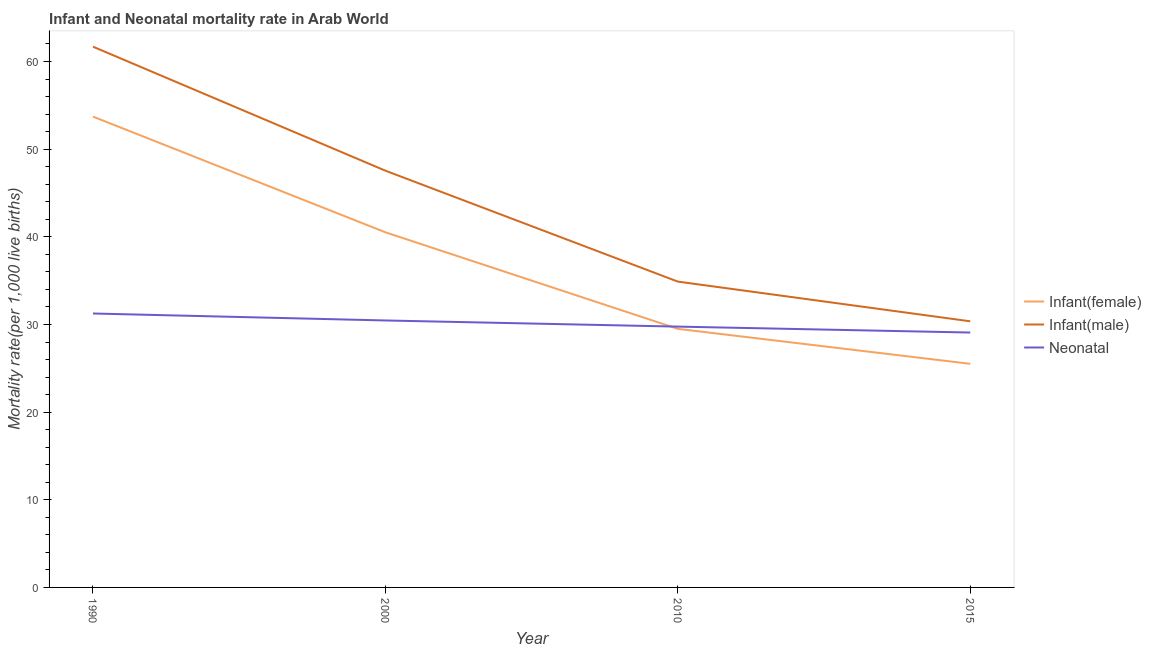How many different coloured lines are there?
Make the answer very short. 3. What is the infant mortality rate(female) in 2015?
Offer a terse response. 25.51. Across all years, what is the maximum neonatal mortality rate?
Provide a short and direct response. 31.25. Across all years, what is the minimum infant mortality rate(male)?
Keep it short and to the point. 30.36. In which year was the infant mortality rate(male) maximum?
Give a very brief answer. 1990. In which year was the infant mortality rate(male) minimum?
Offer a very short reply. 2015. What is the total neonatal mortality rate in the graph?
Your answer should be very brief. 120.54. What is the difference between the neonatal mortality rate in 1990 and that in 2015?
Give a very brief answer. 2.17. What is the difference between the infant mortality rate(female) in 1990 and the infant mortality rate(male) in 2000?
Provide a succinct answer. 6.17. What is the average infant mortality rate(male) per year?
Provide a short and direct response. 43.62. In the year 2015, what is the difference between the infant mortality rate(male) and infant mortality rate(female)?
Your response must be concise. 4.85. In how many years, is the infant mortality rate(male) greater than 44?
Keep it short and to the point. 2. What is the ratio of the infant mortality rate(male) in 1990 to that in 2015?
Provide a short and direct response. 2.03. What is the difference between the highest and the second highest infant mortality rate(male)?
Provide a succinct answer. 14.15. What is the difference between the highest and the lowest neonatal mortality rate?
Make the answer very short. 2.17. Is it the case that in every year, the sum of the infant mortality rate(female) and infant mortality rate(male) is greater than the neonatal mortality rate?
Make the answer very short. Yes. Does the infant mortality rate(female) monotonically increase over the years?
Ensure brevity in your answer.  No. Is the infant mortality rate(female) strictly greater than the infant mortality rate(male) over the years?
Make the answer very short. No. What is the difference between two consecutive major ticks on the Y-axis?
Offer a very short reply. 10. Does the graph contain any zero values?
Give a very brief answer. No. Does the graph contain grids?
Make the answer very short. No. Where does the legend appear in the graph?
Give a very brief answer. Center right. How many legend labels are there?
Give a very brief answer. 3. How are the legend labels stacked?
Give a very brief answer. Vertical. What is the title of the graph?
Your answer should be compact. Infant and Neonatal mortality rate in Arab World. What is the label or title of the X-axis?
Your answer should be compact. Year. What is the label or title of the Y-axis?
Your answer should be compact. Mortality rate(per 1,0 live births). What is the Mortality rate(per 1,000 live births) of Infant(female) in 1990?
Make the answer very short. 53.72. What is the Mortality rate(per 1,000 live births) in Infant(male) in 1990?
Keep it short and to the point. 61.69. What is the Mortality rate(per 1,000 live births) in Neonatal  in 1990?
Provide a succinct answer. 31.25. What is the Mortality rate(per 1,000 live births) in Infant(female) in 2000?
Provide a short and direct response. 40.52. What is the Mortality rate(per 1,000 live births) of Infant(male) in 2000?
Provide a succinct answer. 47.55. What is the Mortality rate(per 1,000 live births) in Neonatal  in 2000?
Your response must be concise. 30.46. What is the Mortality rate(per 1,000 live births) of Infant(female) in 2010?
Provide a short and direct response. 29.5. What is the Mortality rate(per 1,000 live births) in Infant(male) in 2010?
Provide a short and direct response. 34.89. What is the Mortality rate(per 1,000 live births) of Neonatal  in 2010?
Give a very brief answer. 29.76. What is the Mortality rate(per 1,000 live births) in Infant(female) in 2015?
Provide a short and direct response. 25.51. What is the Mortality rate(per 1,000 live births) of Infant(male) in 2015?
Ensure brevity in your answer.  30.36. What is the Mortality rate(per 1,000 live births) of Neonatal  in 2015?
Make the answer very short. 29.08. Across all years, what is the maximum Mortality rate(per 1,000 live births) in Infant(female)?
Keep it short and to the point. 53.72. Across all years, what is the maximum Mortality rate(per 1,000 live births) in Infant(male)?
Offer a terse response. 61.69. Across all years, what is the maximum Mortality rate(per 1,000 live births) in Neonatal ?
Keep it short and to the point. 31.25. Across all years, what is the minimum Mortality rate(per 1,000 live births) of Infant(female)?
Make the answer very short. 25.51. Across all years, what is the minimum Mortality rate(per 1,000 live births) in Infant(male)?
Ensure brevity in your answer.  30.36. Across all years, what is the minimum Mortality rate(per 1,000 live births) in Neonatal ?
Give a very brief answer. 29.08. What is the total Mortality rate(per 1,000 live births) of Infant(female) in the graph?
Offer a very short reply. 149.24. What is the total Mortality rate(per 1,000 live births) in Infant(male) in the graph?
Keep it short and to the point. 174.49. What is the total Mortality rate(per 1,000 live births) in Neonatal  in the graph?
Give a very brief answer. 120.54. What is the difference between the Mortality rate(per 1,000 live births) in Infant(female) in 1990 and that in 2000?
Ensure brevity in your answer.  13.2. What is the difference between the Mortality rate(per 1,000 live births) in Infant(male) in 1990 and that in 2000?
Ensure brevity in your answer.  14.15. What is the difference between the Mortality rate(per 1,000 live births) in Neonatal  in 1990 and that in 2000?
Offer a very short reply. 0.79. What is the difference between the Mortality rate(per 1,000 live births) of Infant(female) in 1990 and that in 2010?
Offer a very short reply. 24.22. What is the difference between the Mortality rate(per 1,000 live births) of Infant(male) in 1990 and that in 2010?
Ensure brevity in your answer.  26.8. What is the difference between the Mortality rate(per 1,000 live births) of Neonatal  in 1990 and that in 2010?
Provide a short and direct response. 1.49. What is the difference between the Mortality rate(per 1,000 live births) in Infant(female) in 1990 and that in 2015?
Give a very brief answer. 28.21. What is the difference between the Mortality rate(per 1,000 live births) in Infant(male) in 1990 and that in 2015?
Offer a terse response. 31.33. What is the difference between the Mortality rate(per 1,000 live births) of Neonatal  in 1990 and that in 2015?
Your answer should be compact. 2.17. What is the difference between the Mortality rate(per 1,000 live births) of Infant(female) in 2000 and that in 2010?
Make the answer very short. 11.02. What is the difference between the Mortality rate(per 1,000 live births) of Infant(male) in 2000 and that in 2010?
Give a very brief answer. 12.65. What is the difference between the Mortality rate(per 1,000 live births) in Neonatal  in 2000 and that in 2010?
Provide a short and direct response. 0.7. What is the difference between the Mortality rate(per 1,000 live births) in Infant(female) in 2000 and that in 2015?
Your answer should be very brief. 15.01. What is the difference between the Mortality rate(per 1,000 live births) of Infant(male) in 2000 and that in 2015?
Make the answer very short. 17.18. What is the difference between the Mortality rate(per 1,000 live births) of Neonatal  in 2000 and that in 2015?
Keep it short and to the point. 1.38. What is the difference between the Mortality rate(per 1,000 live births) in Infant(female) in 2010 and that in 2015?
Provide a short and direct response. 3.99. What is the difference between the Mortality rate(per 1,000 live births) of Infant(male) in 2010 and that in 2015?
Make the answer very short. 4.53. What is the difference between the Mortality rate(per 1,000 live births) of Neonatal  in 2010 and that in 2015?
Offer a terse response. 0.68. What is the difference between the Mortality rate(per 1,000 live births) in Infant(female) in 1990 and the Mortality rate(per 1,000 live births) in Infant(male) in 2000?
Your answer should be compact. 6.17. What is the difference between the Mortality rate(per 1,000 live births) of Infant(female) in 1990 and the Mortality rate(per 1,000 live births) of Neonatal  in 2000?
Make the answer very short. 23.26. What is the difference between the Mortality rate(per 1,000 live births) of Infant(male) in 1990 and the Mortality rate(per 1,000 live births) of Neonatal  in 2000?
Offer a terse response. 31.24. What is the difference between the Mortality rate(per 1,000 live births) of Infant(female) in 1990 and the Mortality rate(per 1,000 live births) of Infant(male) in 2010?
Provide a succinct answer. 18.82. What is the difference between the Mortality rate(per 1,000 live births) of Infant(female) in 1990 and the Mortality rate(per 1,000 live births) of Neonatal  in 2010?
Give a very brief answer. 23.96. What is the difference between the Mortality rate(per 1,000 live births) of Infant(male) in 1990 and the Mortality rate(per 1,000 live births) of Neonatal  in 2010?
Keep it short and to the point. 31.94. What is the difference between the Mortality rate(per 1,000 live births) of Infant(female) in 1990 and the Mortality rate(per 1,000 live births) of Infant(male) in 2015?
Provide a short and direct response. 23.36. What is the difference between the Mortality rate(per 1,000 live births) of Infant(female) in 1990 and the Mortality rate(per 1,000 live births) of Neonatal  in 2015?
Your answer should be compact. 24.64. What is the difference between the Mortality rate(per 1,000 live births) of Infant(male) in 1990 and the Mortality rate(per 1,000 live births) of Neonatal  in 2015?
Offer a very short reply. 32.61. What is the difference between the Mortality rate(per 1,000 live births) of Infant(female) in 2000 and the Mortality rate(per 1,000 live births) of Infant(male) in 2010?
Ensure brevity in your answer.  5.62. What is the difference between the Mortality rate(per 1,000 live births) in Infant(female) in 2000 and the Mortality rate(per 1,000 live births) in Neonatal  in 2010?
Make the answer very short. 10.76. What is the difference between the Mortality rate(per 1,000 live births) of Infant(male) in 2000 and the Mortality rate(per 1,000 live births) of Neonatal  in 2010?
Offer a terse response. 17.79. What is the difference between the Mortality rate(per 1,000 live births) in Infant(female) in 2000 and the Mortality rate(per 1,000 live births) in Infant(male) in 2015?
Provide a succinct answer. 10.16. What is the difference between the Mortality rate(per 1,000 live births) in Infant(female) in 2000 and the Mortality rate(per 1,000 live births) in Neonatal  in 2015?
Make the answer very short. 11.44. What is the difference between the Mortality rate(per 1,000 live births) in Infant(male) in 2000 and the Mortality rate(per 1,000 live births) in Neonatal  in 2015?
Your answer should be compact. 18.47. What is the difference between the Mortality rate(per 1,000 live births) in Infant(female) in 2010 and the Mortality rate(per 1,000 live births) in Infant(male) in 2015?
Provide a short and direct response. -0.86. What is the difference between the Mortality rate(per 1,000 live births) of Infant(female) in 2010 and the Mortality rate(per 1,000 live births) of Neonatal  in 2015?
Your response must be concise. 0.42. What is the difference between the Mortality rate(per 1,000 live births) of Infant(male) in 2010 and the Mortality rate(per 1,000 live births) of Neonatal  in 2015?
Provide a short and direct response. 5.81. What is the average Mortality rate(per 1,000 live births) in Infant(female) per year?
Keep it short and to the point. 37.31. What is the average Mortality rate(per 1,000 live births) of Infant(male) per year?
Provide a succinct answer. 43.62. What is the average Mortality rate(per 1,000 live births) of Neonatal  per year?
Your answer should be very brief. 30.14. In the year 1990, what is the difference between the Mortality rate(per 1,000 live births) in Infant(female) and Mortality rate(per 1,000 live births) in Infant(male)?
Provide a succinct answer. -7.98. In the year 1990, what is the difference between the Mortality rate(per 1,000 live births) of Infant(female) and Mortality rate(per 1,000 live births) of Neonatal ?
Make the answer very short. 22.46. In the year 1990, what is the difference between the Mortality rate(per 1,000 live births) of Infant(male) and Mortality rate(per 1,000 live births) of Neonatal ?
Ensure brevity in your answer.  30.44. In the year 2000, what is the difference between the Mortality rate(per 1,000 live births) of Infant(female) and Mortality rate(per 1,000 live births) of Infant(male)?
Make the answer very short. -7.03. In the year 2000, what is the difference between the Mortality rate(per 1,000 live births) of Infant(female) and Mortality rate(per 1,000 live births) of Neonatal ?
Offer a terse response. 10.06. In the year 2000, what is the difference between the Mortality rate(per 1,000 live births) of Infant(male) and Mortality rate(per 1,000 live births) of Neonatal ?
Offer a terse response. 17.09. In the year 2010, what is the difference between the Mortality rate(per 1,000 live births) in Infant(female) and Mortality rate(per 1,000 live births) in Infant(male)?
Give a very brief answer. -5.39. In the year 2010, what is the difference between the Mortality rate(per 1,000 live births) of Infant(female) and Mortality rate(per 1,000 live births) of Neonatal ?
Offer a terse response. -0.26. In the year 2010, what is the difference between the Mortality rate(per 1,000 live births) of Infant(male) and Mortality rate(per 1,000 live births) of Neonatal ?
Give a very brief answer. 5.13. In the year 2015, what is the difference between the Mortality rate(per 1,000 live births) of Infant(female) and Mortality rate(per 1,000 live births) of Infant(male)?
Your response must be concise. -4.85. In the year 2015, what is the difference between the Mortality rate(per 1,000 live births) in Infant(female) and Mortality rate(per 1,000 live births) in Neonatal ?
Keep it short and to the point. -3.57. In the year 2015, what is the difference between the Mortality rate(per 1,000 live births) in Infant(male) and Mortality rate(per 1,000 live births) in Neonatal ?
Ensure brevity in your answer.  1.28. What is the ratio of the Mortality rate(per 1,000 live births) in Infant(female) in 1990 to that in 2000?
Ensure brevity in your answer.  1.33. What is the ratio of the Mortality rate(per 1,000 live births) of Infant(male) in 1990 to that in 2000?
Offer a terse response. 1.3. What is the ratio of the Mortality rate(per 1,000 live births) of Neonatal  in 1990 to that in 2000?
Give a very brief answer. 1.03. What is the ratio of the Mortality rate(per 1,000 live births) in Infant(female) in 1990 to that in 2010?
Make the answer very short. 1.82. What is the ratio of the Mortality rate(per 1,000 live births) of Infant(male) in 1990 to that in 2010?
Keep it short and to the point. 1.77. What is the ratio of the Mortality rate(per 1,000 live births) of Neonatal  in 1990 to that in 2010?
Make the answer very short. 1.05. What is the ratio of the Mortality rate(per 1,000 live births) in Infant(female) in 1990 to that in 2015?
Keep it short and to the point. 2.11. What is the ratio of the Mortality rate(per 1,000 live births) in Infant(male) in 1990 to that in 2015?
Provide a short and direct response. 2.03. What is the ratio of the Mortality rate(per 1,000 live births) in Neonatal  in 1990 to that in 2015?
Make the answer very short. 1.07. What is the ratio of the Mortality rate(per 1,000 live births) in Infant(female) in 2000 to that in 2010?
Provide a succinct answer. 1.37. What is the ratio of the Mortality rate(per 1,000 live births) of Infant(male) in 2000 to that in 2010?
Make the answer very short. 1.36. What is the ratio of the Mortality rate(per 1,000 live births) of Neonatal  in 2000 to that in 2010?
Your response must be concise. 1.02. What is the ratio of the Mortality rate(per 1,000 live births) of Infant(female) in 2000 to that in 2015?
Your response must be concise. 1.59. What is the ratio of the Mortality rate(per 1,000 live births) of Infant(male) in 2000 to that in 2015?
Give a very brief answer. 1.57. What is the ratio of the Mortality rate(per 1,000 live births) of Neonatal  in 2000 to that in 2015?
Provide a succinct answer. 1.05. What is the ratio of the Mortality rate(per 1,000 live births) in Infant(female) in 2010 to that in 2015?
Provide a succinct answer. 1.16. What is the ratio of the Mortality rate(per 1,000 live births) of Infant(male) in 2010 to that in 2015?
Offer a terse response. 1.15. What is the ratio of the Mortality rate(per 1,000 live births) of Neonatal  in 2010 to that in 2015?
Provide a short and direct response. 1.02. What is the difference between the highest and the second highest Mortality rate(per 1,000 live births) of Infant(female)?
Your answer should be very brief. 13.2. What is the difference between the highest and the second highest Mortality rate(per 1,000 live births) of Infant(male)?
Your answer should be very brief. 14.15. What is the difference between the highest and the second highest Mortality rate(per 1,000 live births) of Neonatal ?
Your answer should be compact. 0.79. What is the difference between the highest and the lowest Mortality rate(per 1,000 live births) in Infant(female)?
Your answer should be compact. 28.21. What is the difference between the highest and the lowest Mortality rate(per 1,000 live births) of Infant(male)?
Your answer should be very brief. 31.33. What is the difference between the highest and the lowest Mortality rate(per 1,000 live births) of Neonatal ?
Your answer should be very brief. 2.17. 